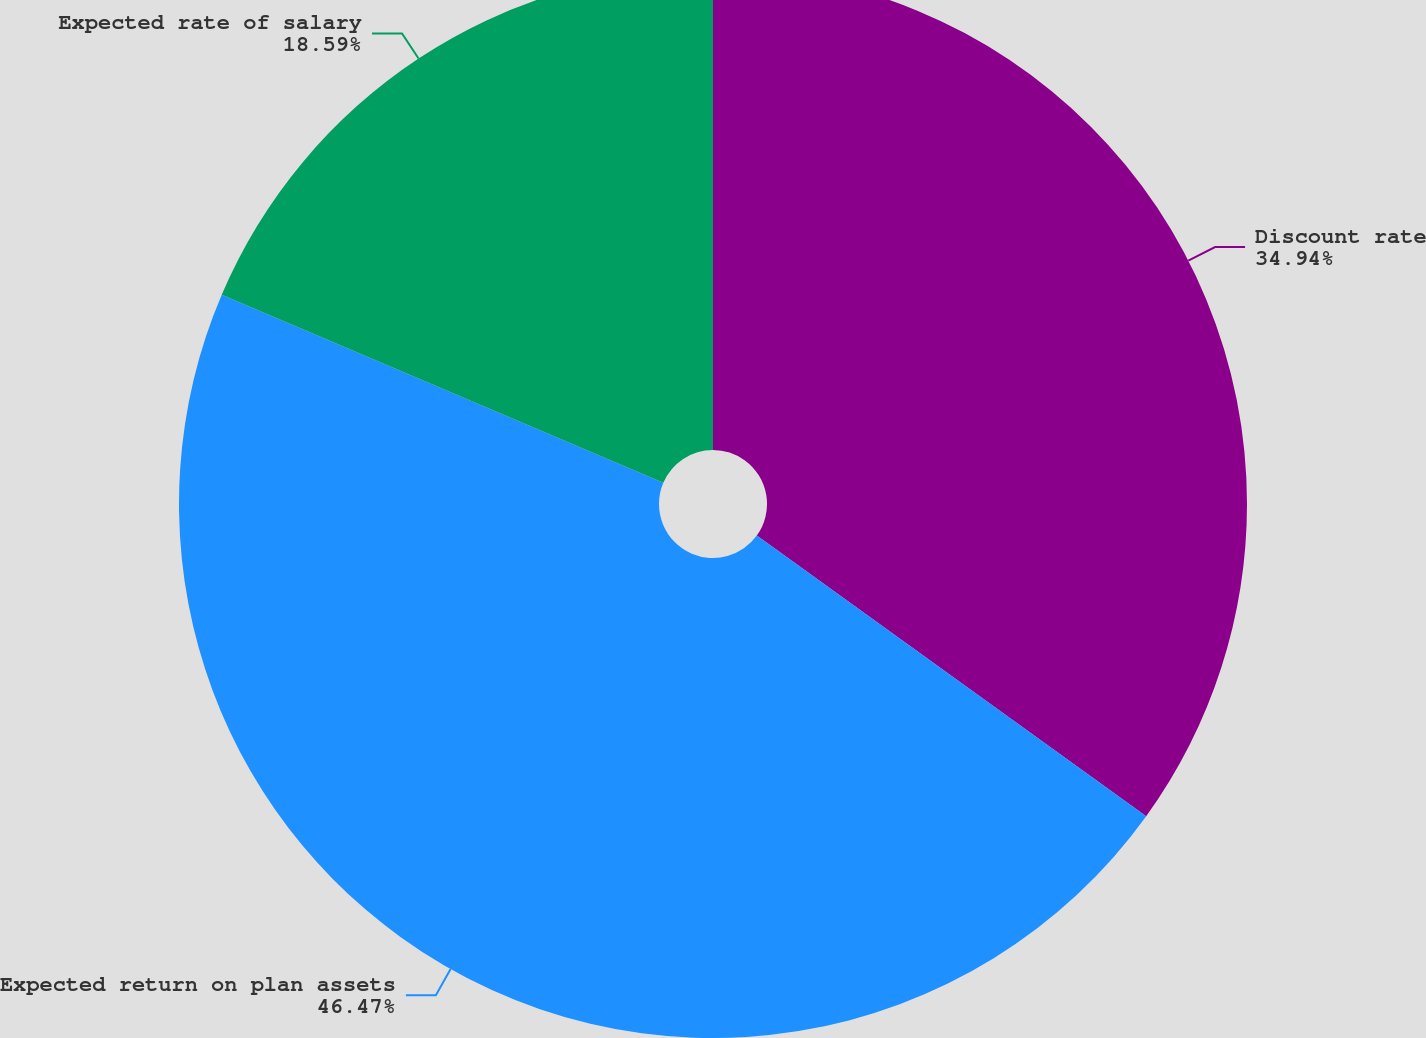Convert chart. <chart><loc_0><loc_0><loc_500><loc_500><pie_chart><fcel>Discount rate<fcel>Expected return on plan assets<fcel>Expected rate of salary<nl><fcel>34.94%<fcel>46.47%<fcel>18.59%<nl></chart> 